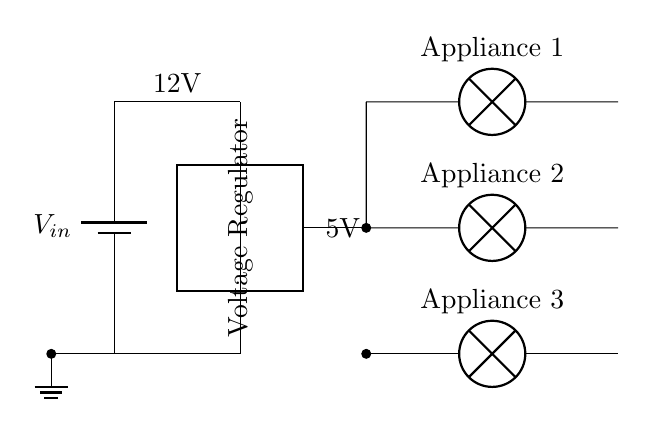What is the input voltage of this circuit? The input voltage is shown to be 12V, indicated by the label at the top left corner of the battery symbol (V_in).
Answer: 12V What is the output voltage provided by the voltage regulator? The output voltage is 5V, which is labeled next to the output connection of the voltage regulator (between the regulator and the appliances).
Answer: 5V How many appliances are connected to the circuit? Three appliances are connected, as indicated by the three lamp symbols on the right side of the circuit diagram.
Answer: 3 What is the function of the voltage regulator in this circuit? The voltage regulator's function is to step down the input voltage (12V) to a lower output voltage (5V) for the appliances, ensuring they receive the correct voltage for operation.
Answer: Step down voltage Where is the ground connection in this circuit? The ground connection is shown at the bottom left of the circuit diagram, indicated by the ground symbol which connects to the 0V of the battery.
Answer: Bottom left What type of components are the connected appliances? The connected appliances are represented as lamp symbols, which indicate that they are lighting devices. This indicates they are likely to be low-power lighting fixtures or similar devices.
Answer: Lamps What is the purpose of using a voltage regulator in a restaurant kitchen? The purpose of using a voltage regulator in a restaurant kitchen is to provide a stable and appropriate voltage for various small kitchen appliances, protecting them from voltage fluctuations and ensuring reliable operation.
Answer: Stability and protection 